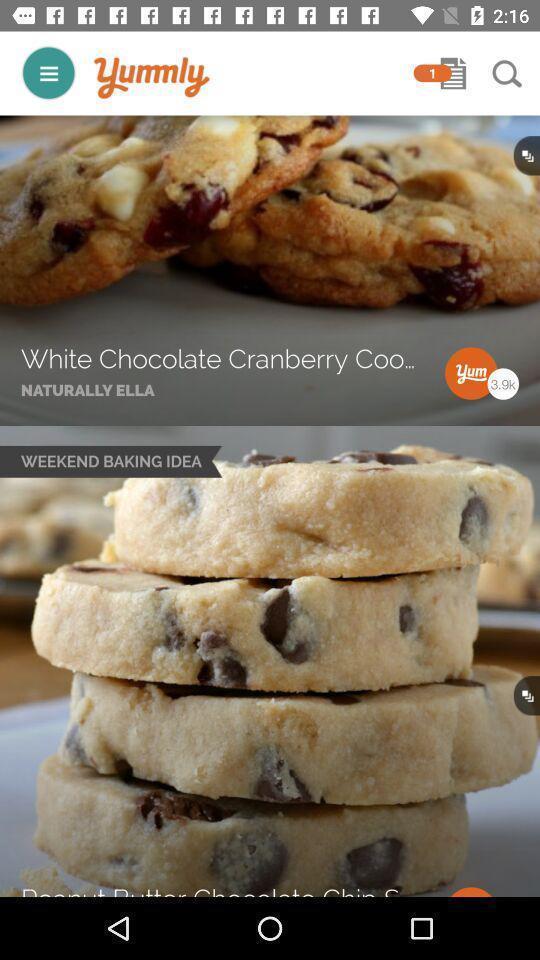Tell me about the visual elements in this screen capture. Screen page of a recipe app. 